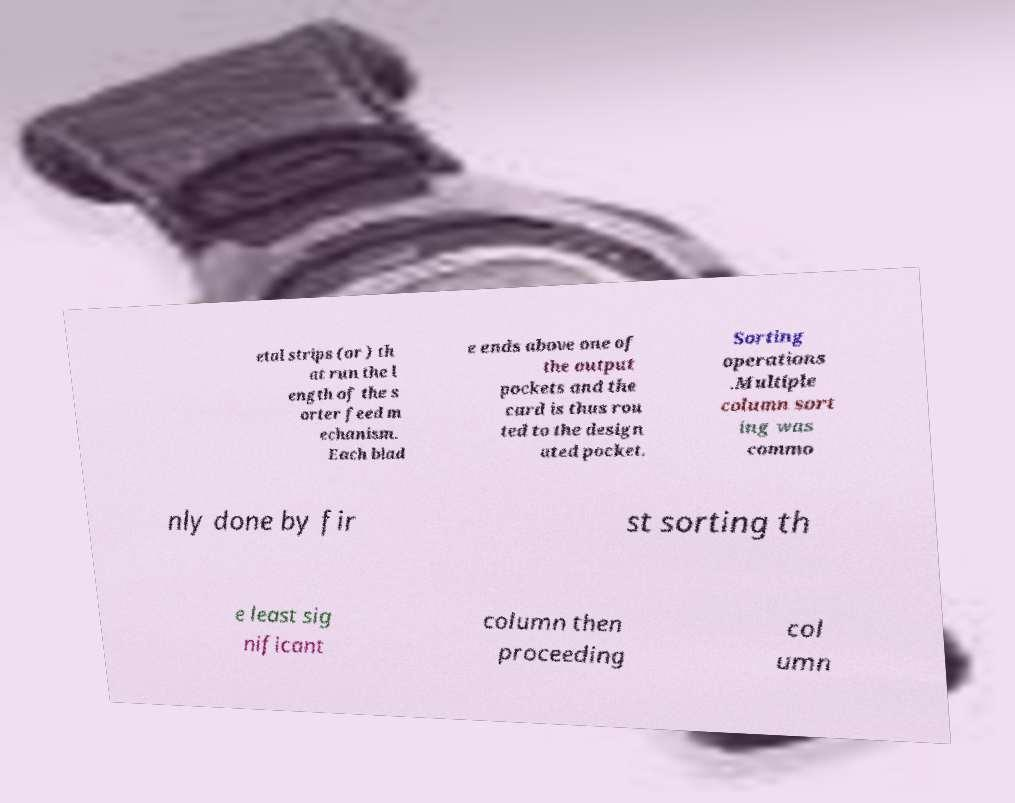Can you accurately transcribe the text from the provided image for me? etal strips (or ) th at run the l ength of the s orter feed m echanism. Each blad e ends above one of the output pockets and the card is thus rou ted to the design ated pocket. Sorting operations .Multiple column sort ing was commo nly done by fir st sorting th e least sig nificant column then proceeding col umn 